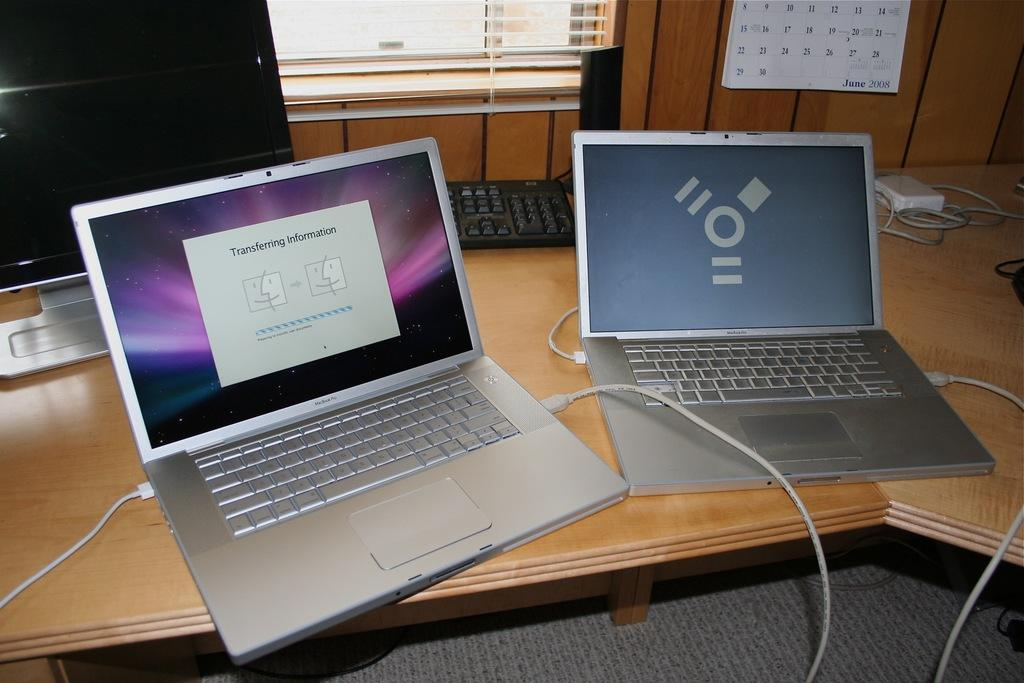Provide a one-sentence caption for the provided image. One macbook is transferring information to the other macbook. 